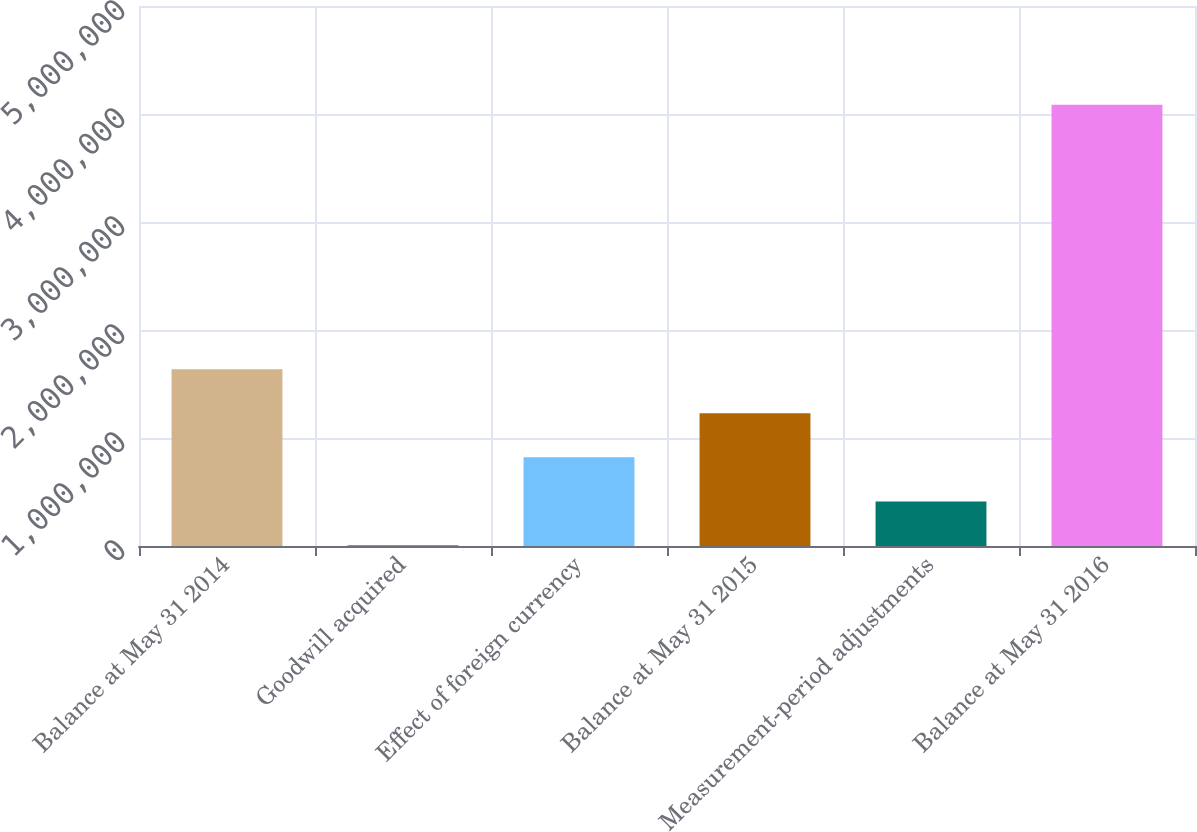Convert chart. <chart><loc_0><loc_0><loc_500><loc_500><bar_chart><fcel>Balance at May 31 2014<fcel>Goodwill acquired<fcel>Effect of foreign currency<fcel>Balance at May 31 2015<fcel>Measurement-period adjustments<fcel>Balance at May 31 2016<nl><fcel>1.63745e+06<fcel>4794<fcel>821121<fcel>1.22928e+06<fcel>412958<fcel>4.08643e+06<nl></chart> 